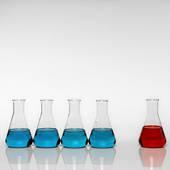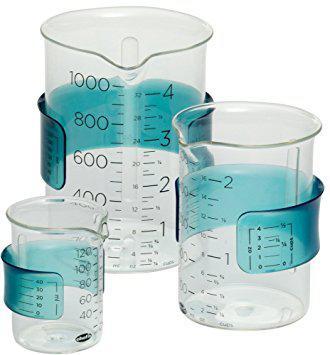The first image is the image on the left, the second image is the image on the right. Examine the images to the left and right. Is the description "Four vases in the image on the left are filled with blue liquid." accurate? Answer yes or no. Yes. The first image is the image on the left, the second image is the image on the right. Evaluate the accuracy of this statement regarding the images: "An image shows an angled row of three of the same type of container shapes, with different colored liquids inside.". Is it true? Answer yes or no. No. 